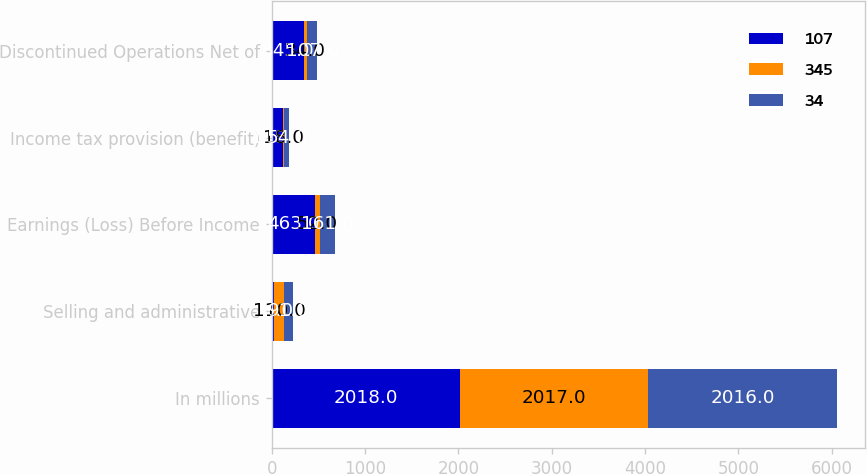Convert chart. <chart><loc_0><loc_0><loc_500><loc_500><stacked_bar_chart><ecel><fcel>In millions<fcel>Selling and administrative<fcel>Earnings (Loss) Before Income<fcel>Income tax provision (benefit)<fcel>Discontinued Operations Net of<nl><fcel>107<fcel>2018<fcel>25<fcel>463<fcel>118<fcel>345<nl><fcel>345<fcel>2017<fcel>110<fcel>52<fcel>18<fcel>34<nl><fcel>34<fcel>2016<fcel>91<fcel>161<fcel>54<fcel>107<nl></chart> 